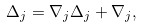Convert formula to latex. <formula><loc_0><loc_0><loc_500><loc_500>\Delta _ { j } = \nabla _ { j } \Delta _ { j } + \nabla _ { j } ,</formula> 